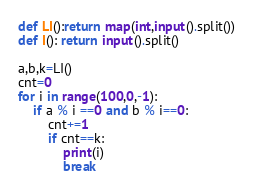<code> <loc_0><loc_0><loc_500><loc_500><_Python_>def LI():return map(int,input().split())
def I(): return input().split()

a,b,k=LI()
cnt=0
for i in range(100,0,-1):
    if a % i ==0 and b % i==0:
        cnt+=1
        if cnt==k:
            print(i)
            break</code> 